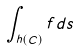<formula> <loc_0><loc_0><loc_500><loc_500>\int _ { h ( C ) } f d s</formula> 